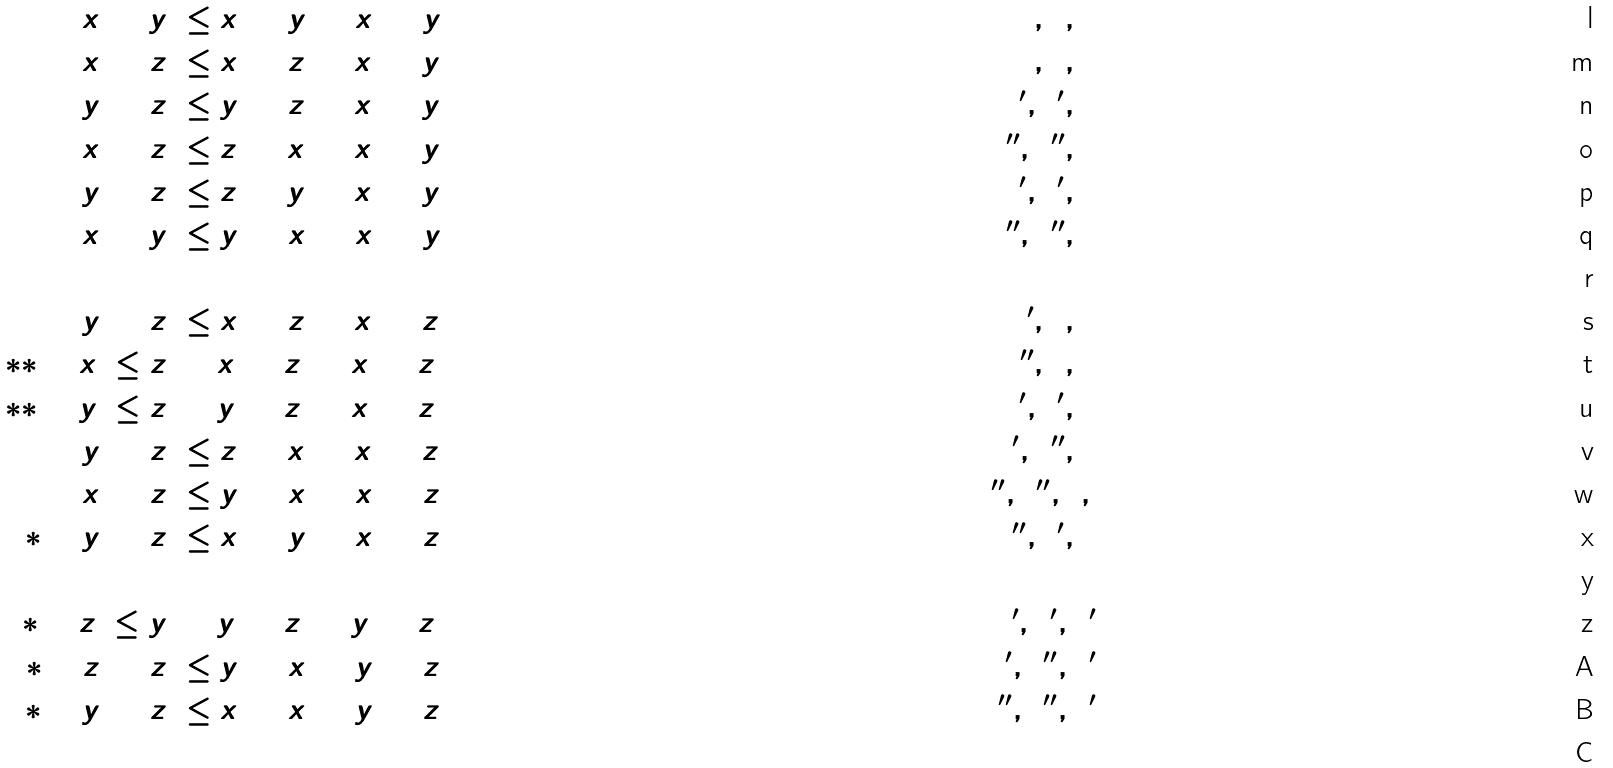<formula> <loc_0><loc_0><loc_500><loc_500>x _ { 1 } + y _ { 1 } & \leq x _ { 2 } + y _ { 2 } + x _ { 3 } + y _ { 3 } \quad & ( 7 , 0 , 0 ) \\ x _ { 1 } + z _ { 1 } & \leq x _ { 2 } + z _ { 2 } + x _ { 3 } + y _ { 3 } \quad & ( 6 , 1 , 0 ) \\ y _ { 1 } + z _ { 1 } & \leq y _ { 2 } + z _ { 2 } + x _ { 3 } + y _ { 3 } \quad & ( 5 ^ { \prime } , 2 ^ { \prime } , 0 ) \\ x _ { 1 } + z _ { 2 } & \leq z _ { 1 } + x _ { 2 } + x _ { 3 } + y _ { 3 } \quad & ( 5 ^ { \prime \prime } , 2 ^ { \prime \prime } , 0 ) \\ y _ { 1 } + z _ { 2 } & \leq z _ { 1 } + y _ { 2 } + x _ { 3 } + y _ { 3 } \quad & ( 4 ^ { \prime } , 3 ^ { \prime } , 0 ) \\ x _ { 1 } + y _ { 2 } & \leq y _ { 1 } + x _ { 2 } + x _ { 3 } + y _ { 3 } \quad & ( 4 ^ { \prime \prime } , 3 ^ { \prime \prime } , 0 ) \\ \ \\ y _ { 1 } + z _ { 1 } & \leq x _ { 2 } + z _ { 2 } + x _ { 3 } + z _ { 3 } \quad & ( 5 ^ { \prime } , 1 , 1 ) \\ ( * * ) \quad x _ { 1 } \leq z _ { 1 } & + x _ { 2 } + z _ { 2 } + x _ { 3 } + z _ { 3 } \quad & ( 5 ^ { \prime \prime } , 1 , 1 ) \\ ( * * ) \quad y _ { 1 } \leq z _ { 1 } & + y _ { 2 } + z _ { 2 } + x _ { 3 } + z _ { 3 } \quad & ( 4 ^ { \prime } , 2 ^ { \prime } , 1 ) \\ y _ { 1 } + z _ { 2 } & \leq z _ { 1 } + x _ { 2 } + x _ { 3 } + z _ { 3 } \quad & ( 4 ^ { \prime } , 2 ^ { \prime \prime } , 1 ) \\ x _ { 1 } + z _ { 2 } & \leq y _ { 1 } + x _ { 2 } + x _ { 3 } + z _ { 3 } \quad & ( 4 ^ { \prime \prime } , 2 ^ { \prime \prime } , 1 , ) \\ ( * ) \quad y _ { 1 } + z _ { 2 } & \leq x _ { 1 } + y _ { 2 } + x _ { 3 } + z _ { 3 } \quad & ( 3 ^ { \prime \prime } , 3 ^ { \prime } , 1 ) \\ \ \\ ( * ) \quad z _ { 1 } \leq y _ { 1 } & + y _ { 2 } + z _ { 2 } + y _ { 3 } + z _ { 3 } \quad & ( 3 ^ { \prime } , 2 ^ { \prime } , 2 ^ { \prime } ) \\ ( * ) \quad z _ { 1 } + z _ { 2 } & \leq y _ { 1 } + x _ { 2 } + y _ { 3 } + z _ { 3 } \quad & ( 3 ^ { \prime } , 2 ^ { \prime \prime } , 2 ^ { \prime } ) \\ ( * ) \quad y _ { 1 } + z _ { 2 } & \leq x _ { 1 } + x _ { 2 } + y _ { 3 } + z _ { 3 } \quad & ( 3 ^ { \prime \prime } , 2 ^ { \prime \prime } , 2 ^ { \prime } ) \\</formula> 